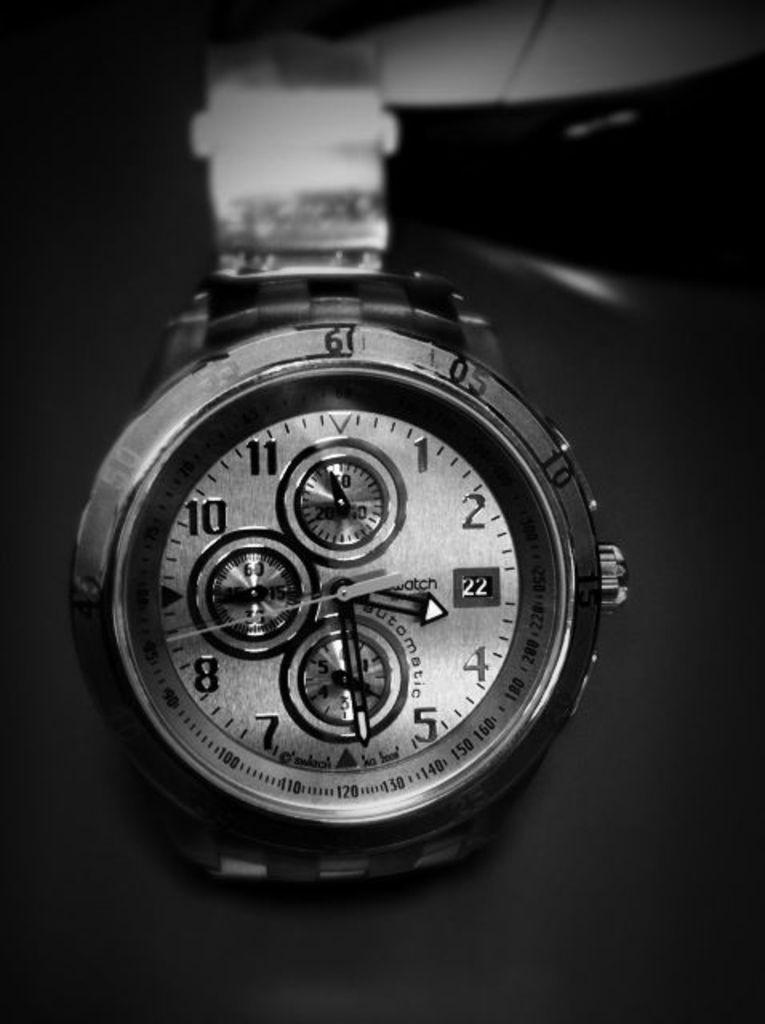What time does it say?
Provide a short and direct response. 3:29. 